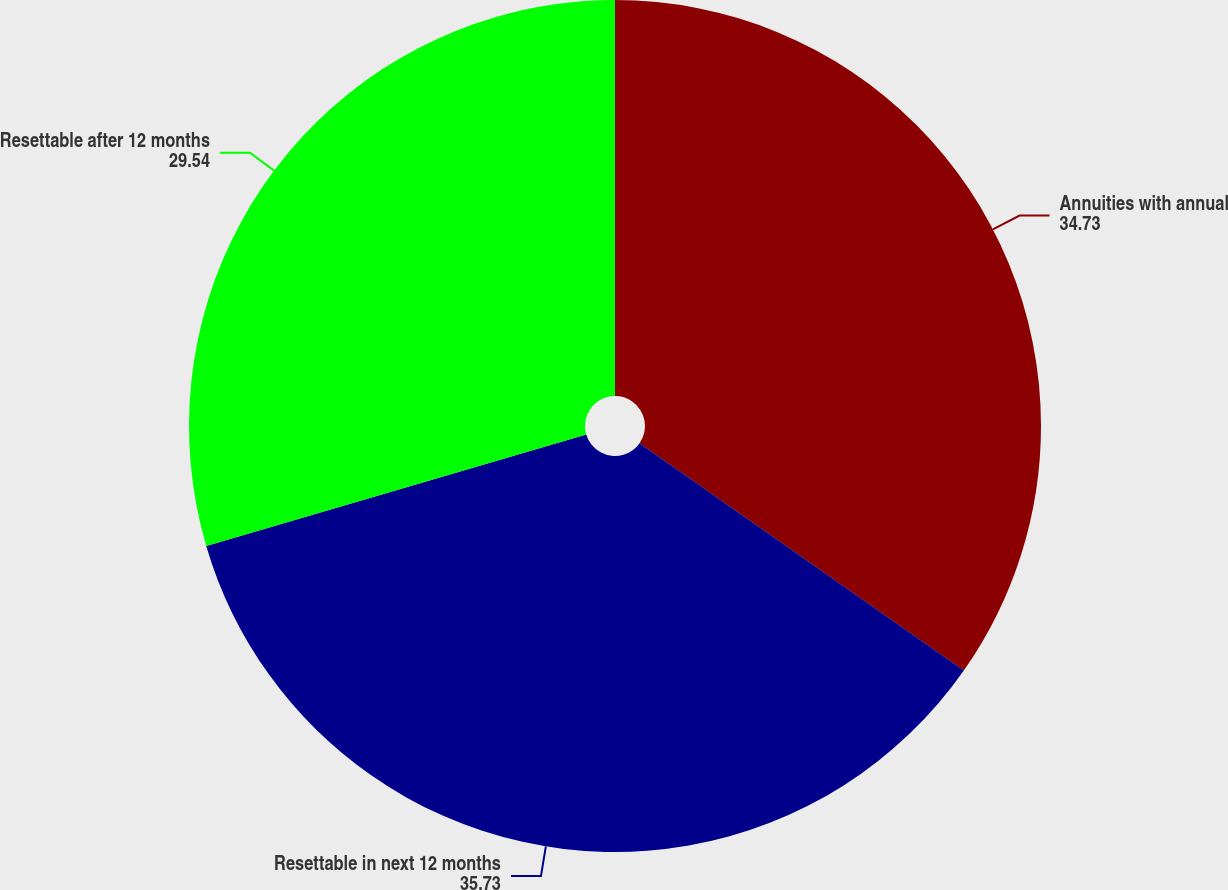Convert chart. <chart><loc_0><loc_0><loc_500><loc_500><pie_chart><fcel>Annuities with annual<fcel>Resettable in next 12 months<fcel>Resettable after 12 months<nl><fcel>34.73%<fcel>35.73%<fcel>29.54%<nl></chart> 